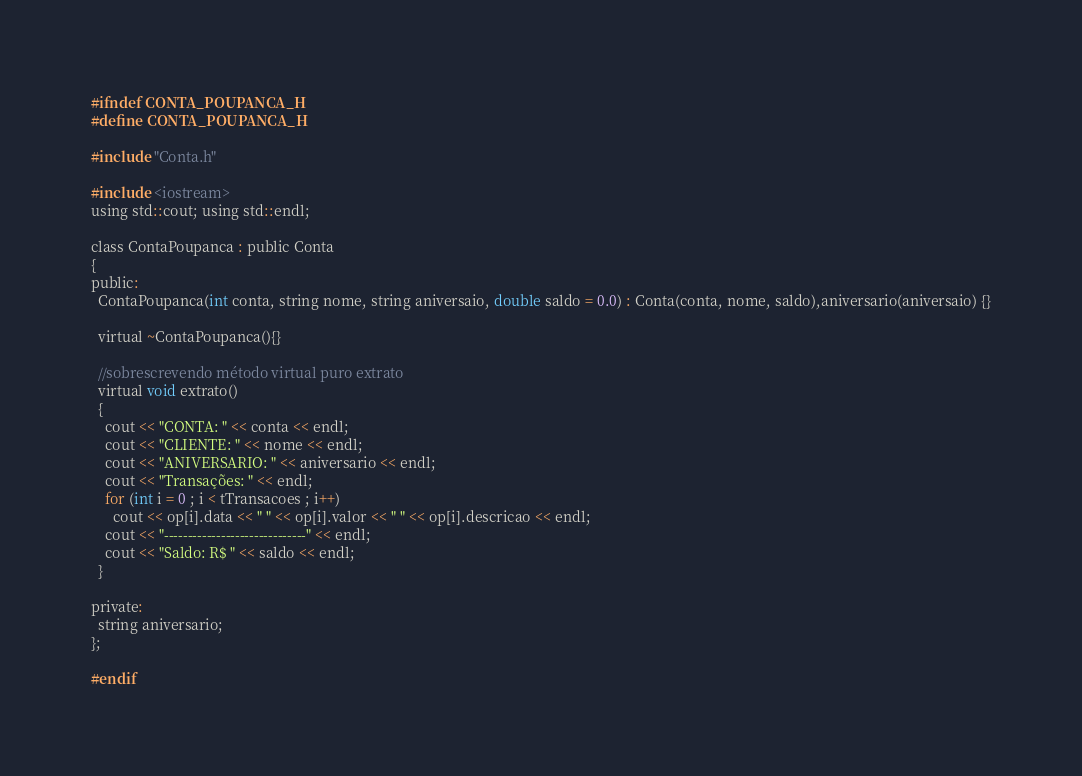Convert code to text. <code><loc_0><loc_0><loc_500><loc_500><_C_>#ifndef CONTA_POUPANCA_H
#define CONTA_POUPANCA_H

#include "Conta.h"

#include <iostream>
using std::cout; using std::endl;

class ContaPoupanca : public Conta
{
public:
  ContaPoupanca(int conta, string nome, string aniversaio, double saldo = 0.0) : Conta(conta, nome, saldo),aniversario(aniversaio) {}
  
  virtual ~ContaPoupanca(){}

  //sobrescrevendo método virtual puro extrato
  virtual void extrato()
  {
    cout << "CONTA: " << conta << endl;
    cout << "CLIENTE: " << nome << endl;
    cout << "ANIVERSARIO: " << aniversario << endl;
    cout << "Transações: " << endl;
    for (int i = 0 ; i < tTransacoes ; i++)
      cout << op[i].data << " " << op[i].valor << " " << op[i].descricao << endl;
    cout << "------------------------------" << endl;
    cout << "Saldo: R$ " << saldo << endl;
  }

private:
  string aniversario;
};

#endif</code> 